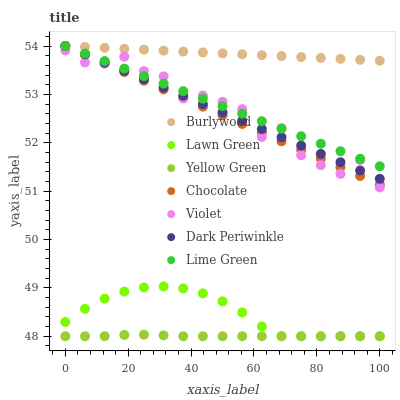Does Yellow Green have the minimum area under the curve?
Answer yes or no. Yes. Does Burlywood have the maximum area under the curve?
Answer yes or no. Yes. Does Burlywood have the minimum area under the curve?
Answer yes or no. No. Does Yellow Green have the maximum area under the curve?
Answer yes or no. No. Is Chocolate the smoothest?
Answer yes or no. Yes. Is Violet the roughest?
Answer yes or no. Yes. Is Yellow Green the smoothest?
Answer yes or no. No. Is Yellow Green the roughest?
Answer yes or no. No. Does Lawn Green have the lowest value?
Answer yes or no. Yes. Does Burlywood have the lowest value?
Answer yes or no. No. Does Dark Periwinkle have the highest value?
Answer yes or no. Yes. Does Yellow Green have the highest value?
Answer yes or no. No. Is Lawn Green less than Violet?
Answer yes or no. Yes. Is Dark Periwinkle greater than Yellow Green?
Answer yes or no. Yes. Does Chocolate intersect Dark Periwinkle?
Answer yes or no. Yes. Is Chocolate less than Dark Periwinkle?
Answer yes or no. No. Is Chocolate greater than Dark Periwinkle?
Answer yes or no. No. Does Lawn Green intersect Violet?
Answer yes or no. No. 